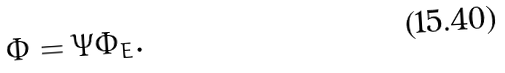<formula> <loc_0><loc_0><loc_500><loc_500>\Phi = \Psi \Phi _ { E } .</formula> 